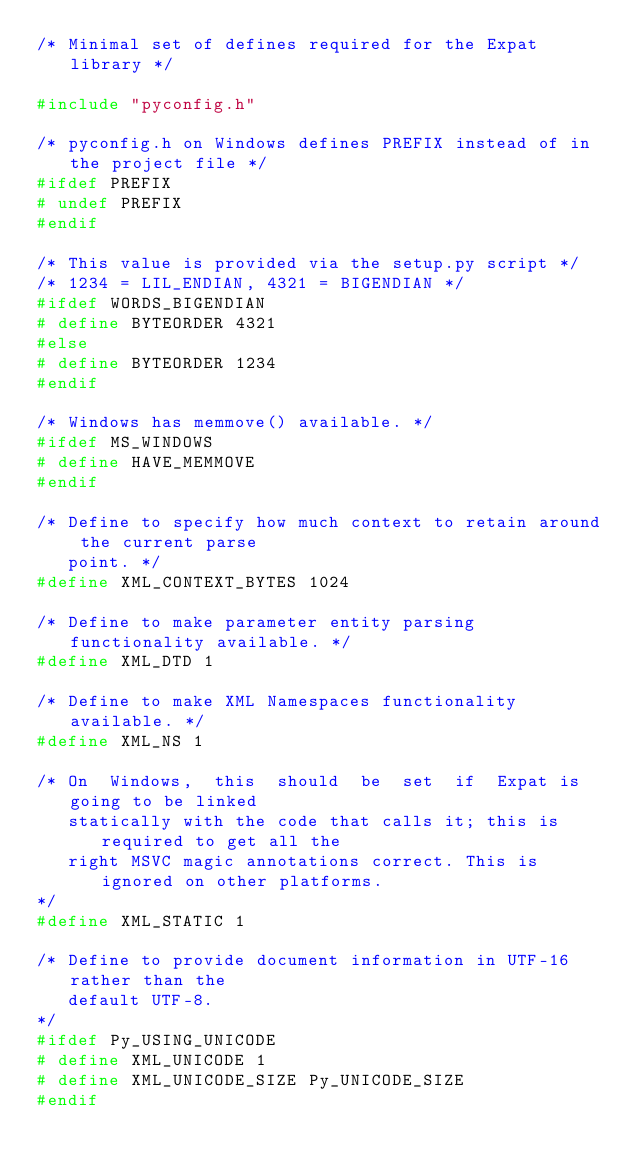<code> <loc_0><loc_0><loc_500><loc_500><_C_>/* Minimal set of defines required for the Expat library */

#include "pyconfig.h"

/* pyconfig.h on Windows defines PREFIX instead of in the project file */
#ifdef PREFIX
# undef PREFIX
#endif

/* This value is provided via the setup.py script */
/* 1234 = LIL_ENDIAN, 4321 = BIGENDIAN */
#ifdef WORDS_BIGENDIAN
# define BYTEORDER 4321
#else
# define BYTEORDER 1234
#endif

/* Windows has memmove() available. */
#ifdef MS_WINDOWS
# define HAVE_MEMMOVE
#endif

/* Define to specify how much context to retain around the current parse
   point. */
#define XML_CONTEXT_BYTES 1024

/* Define to make parameter entity parsing functionality available. */
#define XML_DTD 1

/* Define to make XML Namespaces functionality available. */
#define XML_NS 1

/* On  Windows,  this  should  be  set  if  Expat is going to be linked
   statically with the code that calls it; this is required to get all the
   right MSVC magic annotations correct. This is ignored on other platforms.
*/
#define XML_STATIC 1

/* Define to provide document information in UTF-16 rather than the
   default UTF-8.
*/
#ifdef Py_USING_UNICODE
# define XML_UNICODE 1
# define XML_UNICODE_SIZE Py_UNICODE_SIZE
#endif
</code> 